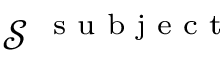Convert formula to latex. <formula><loc_0><loc_0><loc_500><loc_500>\mathcal { S } ^ { s u b j e c t }</formula> 